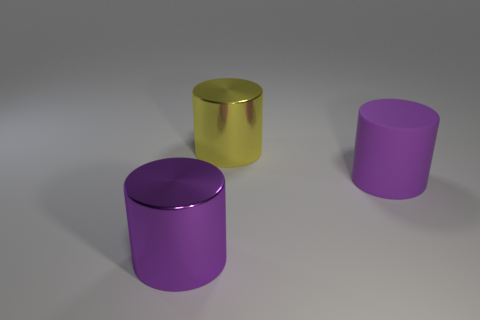What color is the metallic object behind the large metallic object that is in front of the rubber object?
Offer a terse response. Yellow. What number of yellow shiny things are there?
Provide a succinct answer. 1. How many cylinders are in front of the yellow thing and left of the large purple matte object?
Make the answer very short. 1. Do the big matte cylinder and the large metal cylinder in front of the yellow cylinder have the same color?
Your answer should be compact. Yes. The metallic thing behind the big rubber object has what shape?
Ensure brevity in your answer.  Cylinder. What material is the large yellow thing?
Keep it short and to the point. Metal. How many tiny things are yellow things or rubber cylinders?
Provide a succinct answer. 0. What number of large shiny cylinders are behind the purple rubber cylinder?
Provide a short and direct response. 1. Are there any other cylinders that have the same color as the large matte cylinder?
Provide a short and direct response. Yes. There is a purple rubber object that is the same size as the yellow object; what is its shape?
Offer a terse response. Cylinder. 